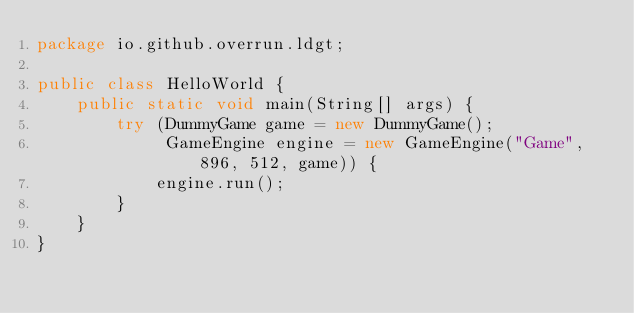<code> <loc_0><loc_0><loc_500><loc_500><_Java_>package io.github.overrun.ldgt;

public class HelloWorld {
	public static void main(String[] args) {
		try (DummyGame game = new DummyGame();
			 GameEngine engine = new GameEngine("Game", 896, 512, game)) {
			engine.run();
		}
	}
}
</code> 